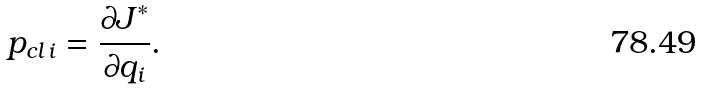Convert formula to latex. <formula><loc_0><loc_0><loc_500><loc_500>p _ { c l \, i } = \frac { \partial J ^ { \ast } } { \partial q _ { i } } .</formula> 